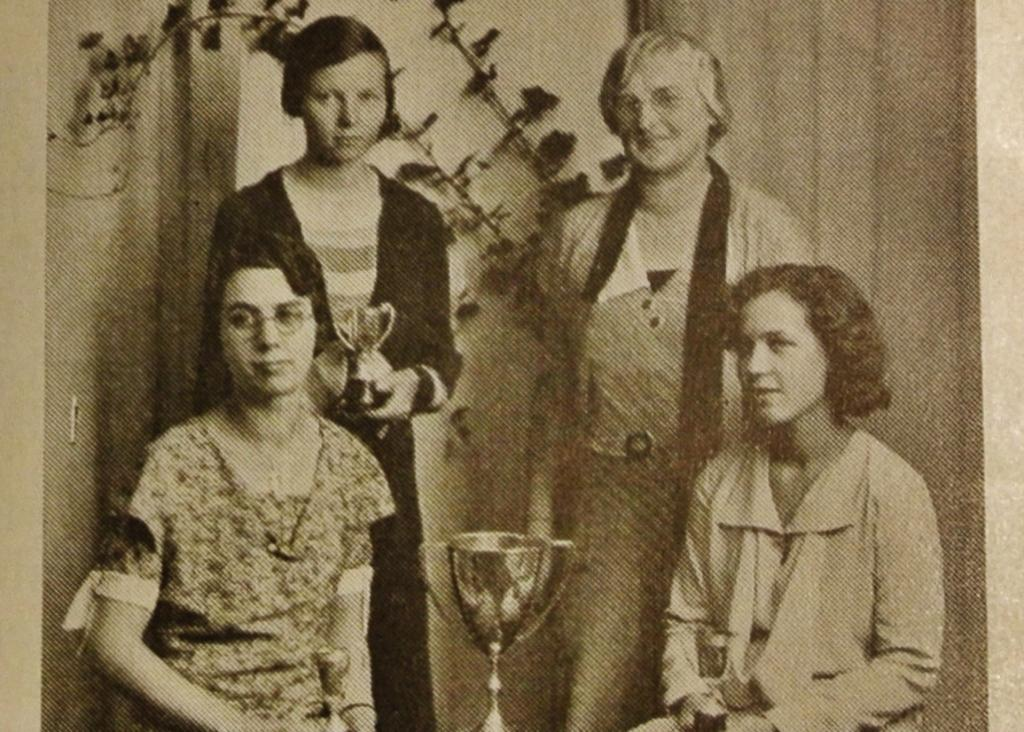What is the color scheme of the image? The image is black and white. How many women are present in the image? There are four women in the image. What objects can be seen in the image that might indicate an achievement or success? There are trophies in the image. What type of vegetation is present in the image? There is a plant in the image. What can be seen in the background of the image? There is a wall and curtains in the background of the image. What type of shoes are the women wearing in the image? There is no information about shoes in the image, as it is black and white and does not show any footwear. Can you tell me how many tubs are visible in the image? There are no tubs present in the image. 